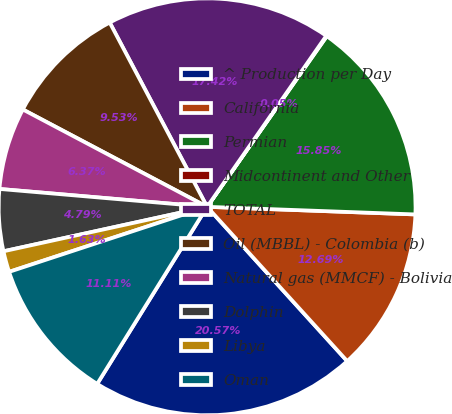<chart> <loc_0><loc_0><loc_500><loc_500><pie_chart><fcel>^ Production per Day<fcel>California<fcel>Permian<fcel>Midcontinent and Other<fcel>TOTAL<fcel>Oil (MBBL) - Colombia (b)<fcel>Natural gas (MMCF) - Bolivia<fcel>Dolphin<fcel>Libya<fcel>Oman<nl><fcel>20.58%<fcel>12.69%<fcel>15.85%<fcel>0.05%<fcel>17.43%<fcel>9.53%<fcel>6.37%<fcel>4.79%<fcel>1.63%<fcel>11.11%<nl></chart> 